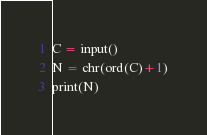Convert code to text. <code><loc_0><loc_0><loc_500><loc_500><_Python_>C = input()
N = chr(ord(C)+1)
print(N)</code> 